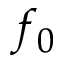<formula> <loc_0><loc_0><loc_500><loc_500>f _ { 0 }</formula> 